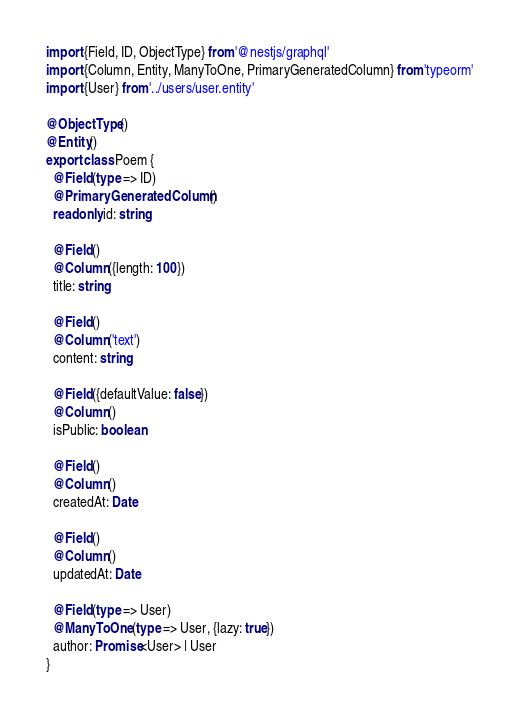<code> <loc_0><loc_0><loc_500><loc_500><_TypeScript_>import {Field, ID, ObjectType} from '@nestjs/graphql'
import {Column, Entity, ManyToOne, PrimaryGeneratedColumn} from 'typeorm'
import {User} from '../users/user.entity'

@ObjectType()
@Entity()
export class Poem {
  @Field(type => ID)
  @PrimaryGeneratedColumn()
  readonly id: string

  @Field()
  @Column({length: 100})
  title: string

  @Field()
  @Column('text')
  content: string

  @Field({defaultValue: false})
  @Column()
  isPublic: boolean

  @Field()
  @Column()
  createdAt: Date

  @Field()
  @Column()
  updatedAt: Date

  @Field(type => User)
  @ManyToOne(type => User, {lazy: true})
  author: Promise<User> | User
}
</code> 